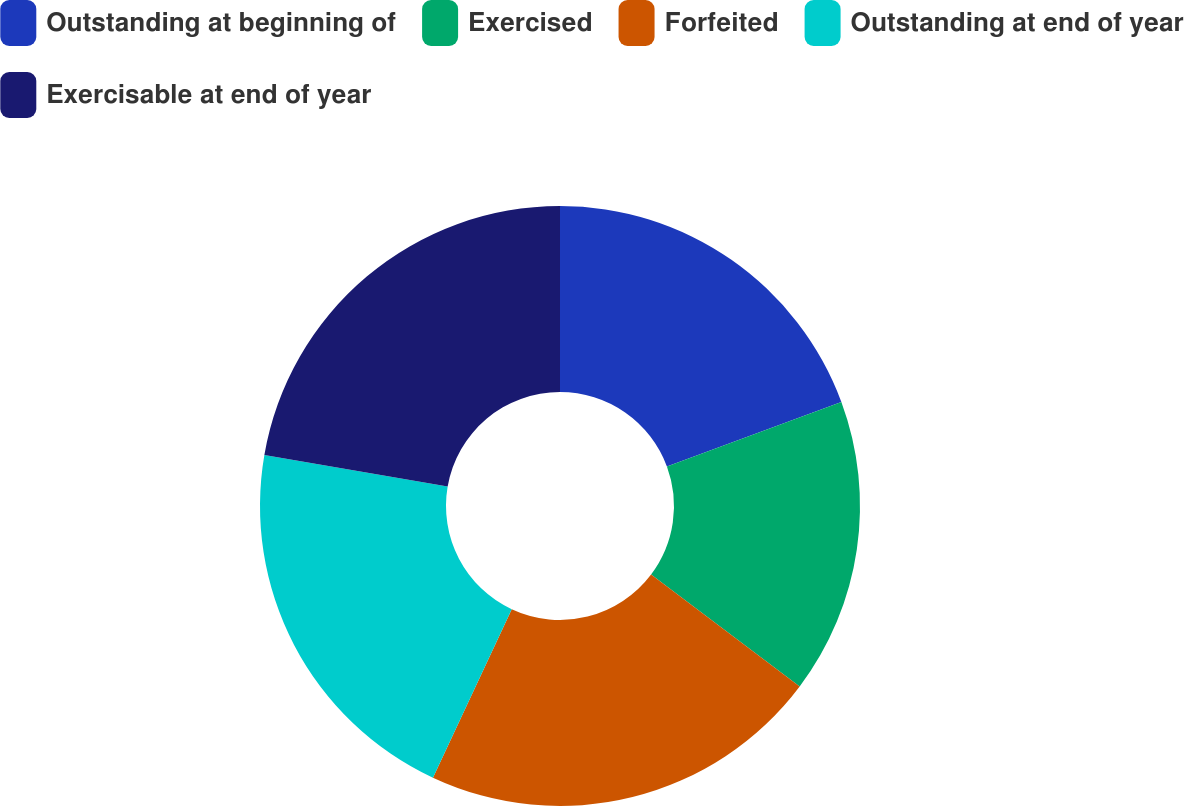<chart> <loc_0><loc_0><loc_500><loc_500><pie_chart><fcel>Outstanding at beginning of<fcel>Exercised<fcel>Forfeited<fcel>Outstanding at end of year<fcel>Exercisable at end of year<nl><fcel>19.36%<fcel>15.91%<fcel>21.69%<fcel>20.76%<fcel>22.28%<nl></chart> 